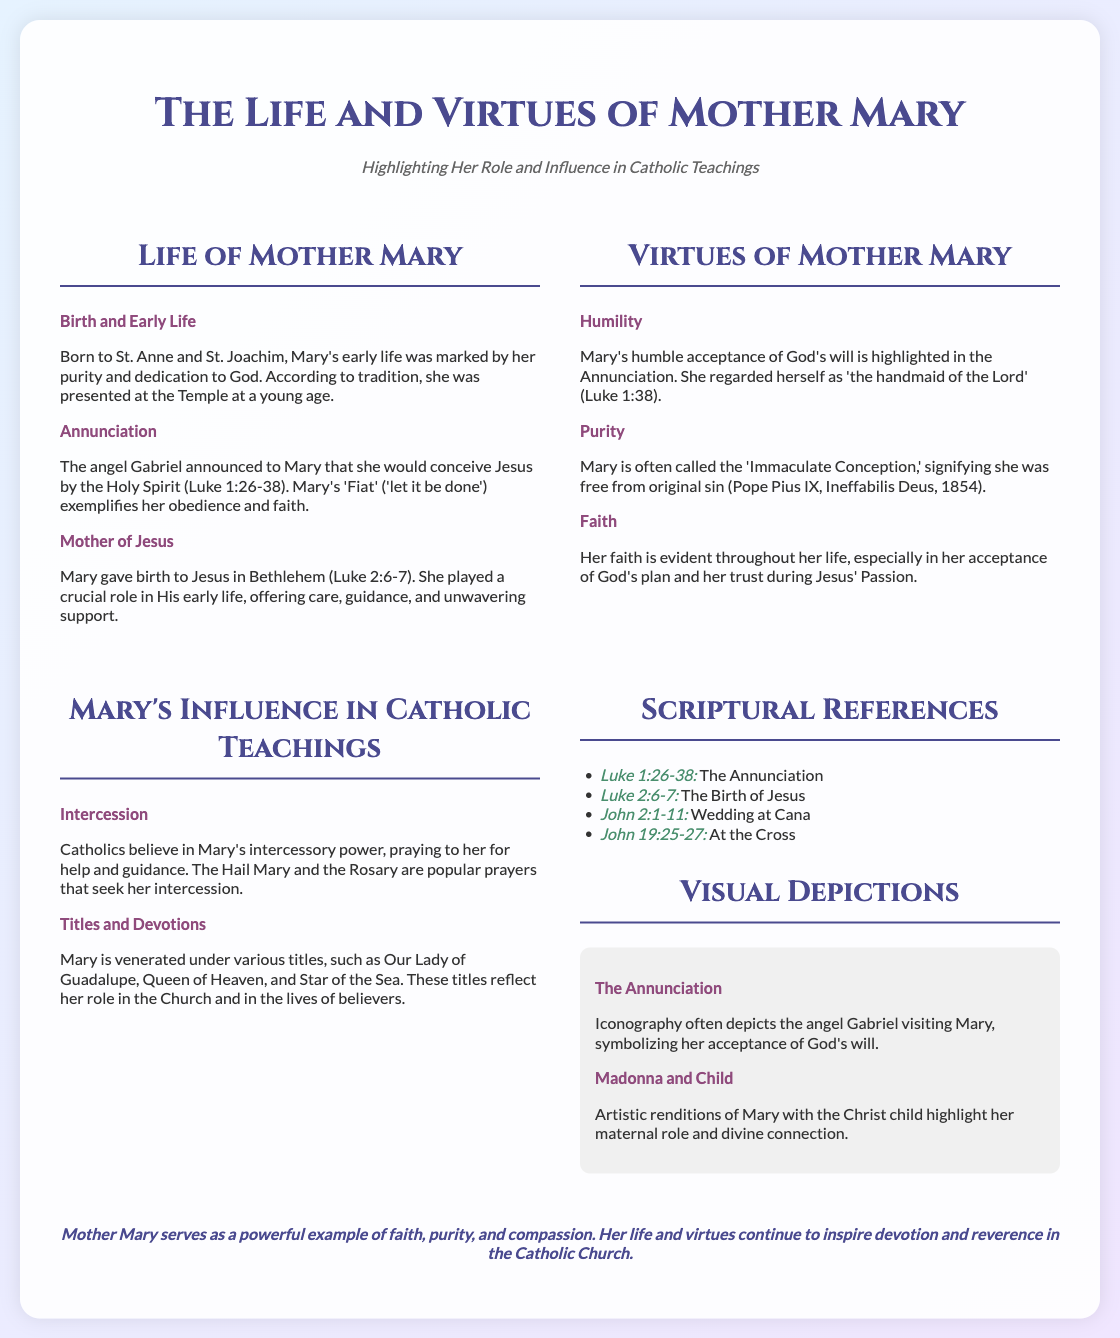What is the title of the presentation? The title is explicitly stated at the top of the document.
Answer: The Life and Virtues of Mother Mary Who are Mary's parents? The document states that Mary was born to St. Anne and St. Joachim.
Answer: St. Anne and St. Joachim What is the significance of 'Fiat'? 'Fiat' refers to Mary's response during the Annunciation, showcasing her obedience.
Answer: Obedience Which scripture references the Birth of Jesus? The document lists scripture that corresponds to specific events.
Answer: Luke 2:6-7 What virtue is associated with Mary as the 'Immaculate Conception'? The document mentions specific virtues linked to Mary.
Answer: Purity Name a title under which Mary is venerated. The document lists different titles given to Mary.
Answer: Our Lady of Guadalupe What event does John 19:25-27 refer to? The document provides scripture references for significant events in Mary's life.
Answer: At the Cross What visual depiction symbolizes Mary's acceptance of God's will? The document discusses visual symbols associated with Mary.
Answer: The Annunciation What role does Mary play in the lives of believers according to Catholic teachings? The document describes Mary's influence and role in Catholic faith.
Answer: Intercession 